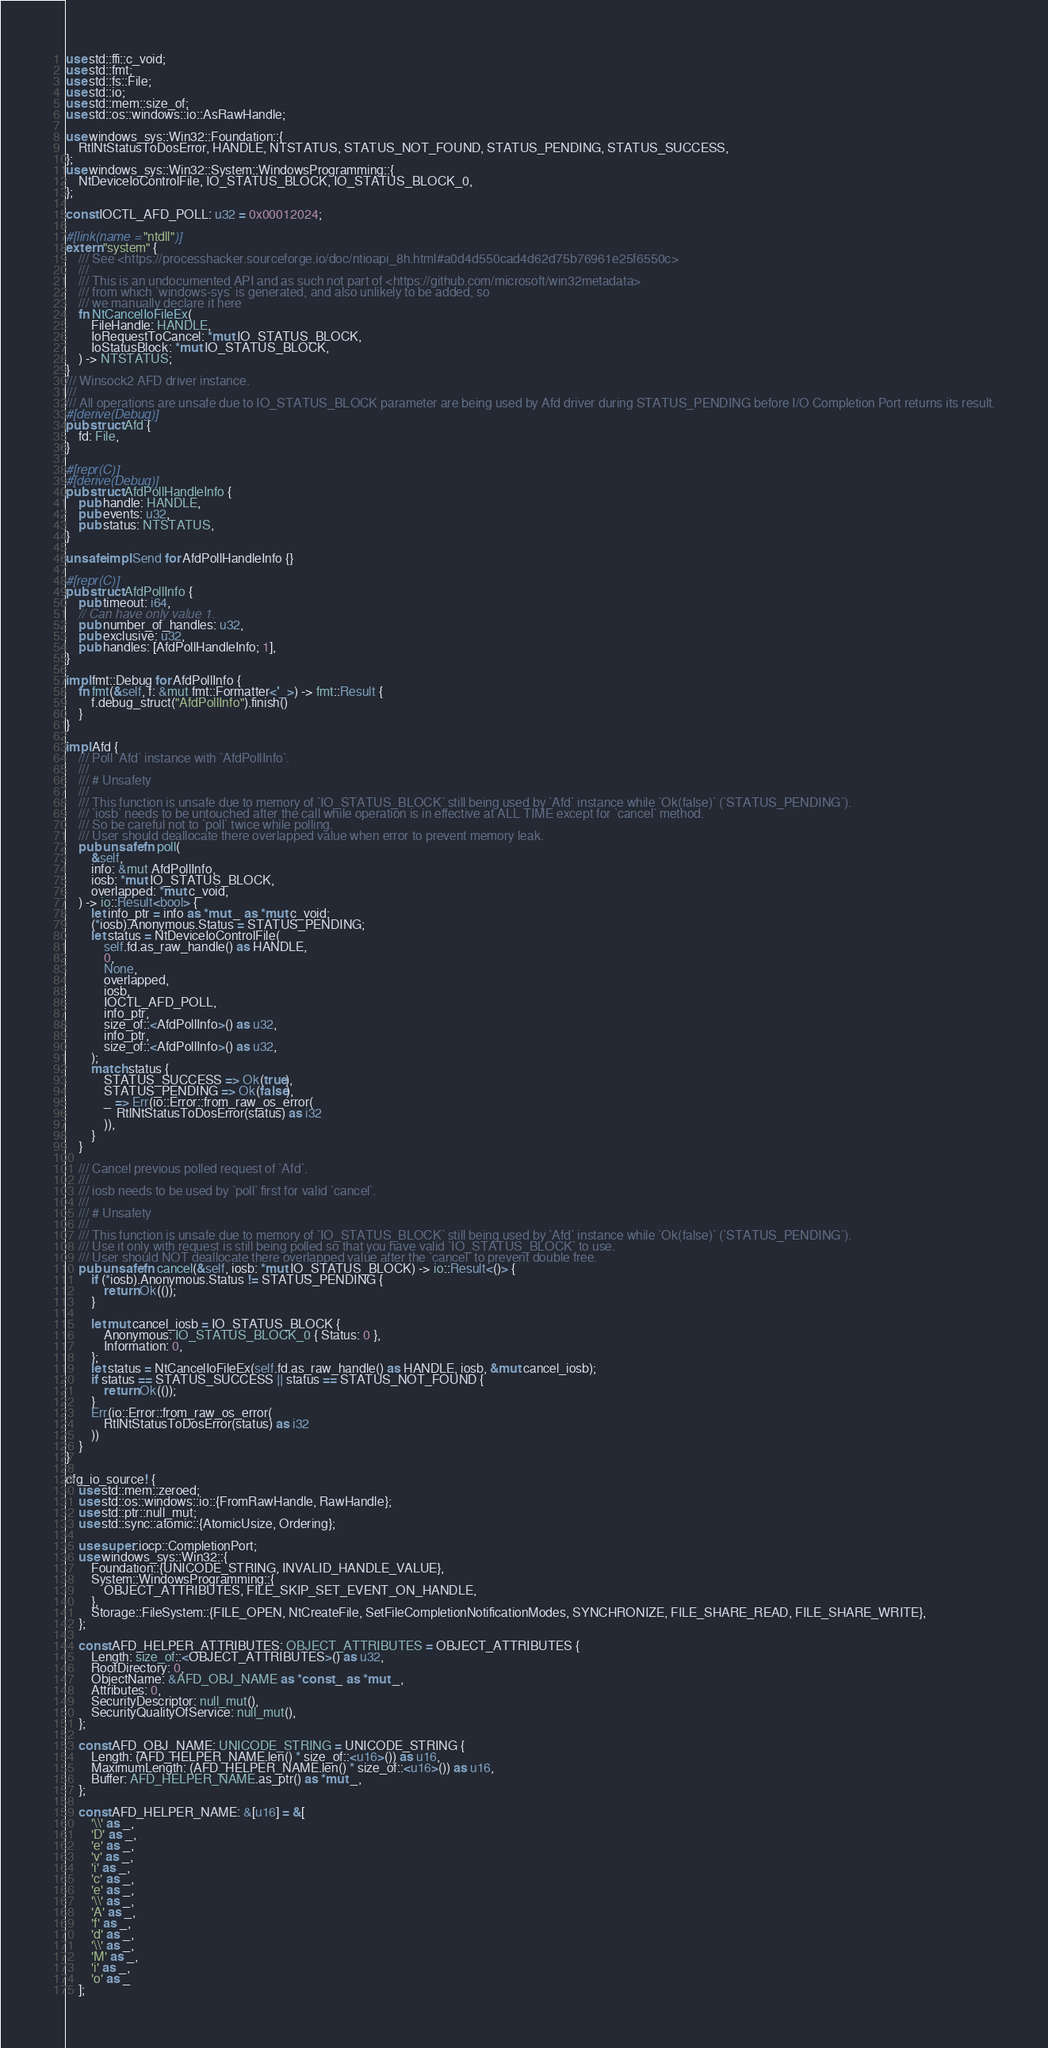<code> <loc_0><loc_0><loc_500><loc_500><_Rust_>use std::ffi::c_void;
use std::fmt;
use std::fs::File;
use std::io;
use std::mem::size_of;
use std::os::windows::io::AsRawHandle;

use windows_sys::Win32::Foundation::{
    RtlNtStatusToDosError, HANDLE, NTSTATUS, STATUS_NOT_FOUND, STATUS_PENDING, STATUS_SUCCESS,
};
use windows_sys::Win32::System::WindowsProgramming::{
    NtDeviceIoControlFile, IO_STATUS_BLOCK, IO_STATUS_BLOCK_0,
};

const IOCTL_AFD_POLL: u32 = 0x00012024;

#[link(name = "ntdll")]
extern "system" {
    /// See <https://processhacker.sourceforge.io/doc/ntioapi_8h.html#a0d4d550cad4d62d75b76961e25f6550c>
    ///
    /// This is an undocumented API and as such not part of <https://github.com/microsoft/win32metadata>
    /// from which `windows-sys` is generated, and also unlikely to be added, so
    /// we manually declare it here
    fn NtCancelIoFileEx(
        FileHandle: HANDLE,
        IoRequestToCancel: *mut IO_STATUS_BLOCK,
        IoStatusBlock: *mut IO_STATUS_BLOCK,
    ) -> NTSTATUS;
}
/// Winsock2 AFD driver instance.
///
/// All operations are unsafe due to IO_STATUS_BLOCK parameter are being used by Afd driver during STATUS_PENDING before I/O Completion Port returns its result.
#[derive(Debug)]
pub struct Afd {
    fd: File,
}

#[repr(C)]
#[derive(Debug)]
pub struct AfdPollHandleInfo {
    pub handle: HANDLE,
    pub events: u32,
    pub status: NTSTATUS,
}

unsafe impl Send for AfdPollHandleInfo {}

#[repr(C)]
pub struct AfdPollInfo {
    pub timeout: i64,
    // Can have only value 1.
    pub number_of_handles: u32,
    pub exclusive: u32,
    pub handles: [AfdPollHandleInfo; 1],
}

impl fmt::Debug for AfdPollInfo {
    fn fmt(&self, f: &mut fmt::Formatter<'_>) -> fmt::Result {
        f.debug_struct("AfdPollInfo").finish()
    }
}

impl Afd {
    /// Poll `Afd` instance with `AfdPollInfo`.
    ///
    /// # Unsafety
    ///
    /// This function is unsafe due to memory of `IO_STATUS_BLOCK` still being used by `Afd` instance while `Ok(false)` (`STATUS_PENDING`).
    /// `iosb` needs to be untouched after the call while operation is in effective at ALL TIME except for `cancel` method.
    /// So be careful not to `poll` twice while polling.
    /// User should deallocate there overlapped value when error to prevent memory leak.
    pub unsafe fn poll(
        &self,
        info: &mut AfdPollInfo,
        iosb: *mut IO_STATUS_BLOCK,
        overlapped: *mut c_void,
    ) -> io::Result<bool> {
        let info_ptr = info as *mut _ as *mut c_void;
        (*iosb).Anonymous.Status = STATUS_PENDING;
        let status = NtDeviceIoControlFile(
            self.fd.as_raw_handle() as HANDLE,
            0,
            None,
            overlapped,
            iosb,
            IOCTL_AFD_POLL,
            info_ptr,
            size_of::<AfdPollInfo>() as u32,
            info_ptr,
            size_of::<AfdPollInfo>() as u32,
        );
        match status {
            STATUS_SUCCESS => Ok(true),
            STATUS_PENDING => Ok(false),
            _ => Err(io::Error::from_raw_os_error(
                RtlNtStatusToDosError(status) as i32
            )),
        }
    }

    /// Cancel previous polled request of `Afd`.
    ///
    /// iosb needs to be used by `poll` first for valid `cancel`.
    ///
    /// # Unsafety
    ///
    /// This function is unsafe due to memory of `IO_STATUS_BLOCK` still being used by `Afd` instance while `Ok(false)` (`STATUS_PENDING`).
    /// Use it only with request is still being polled so that you have valid `IO_STATUS_BLOCK` to use.
    /// User should NOT deallocate there overlapped value after the `cancel` to prevent double free.
    pub unsafe fn cancel(&self, iosb: *mut IO_STATUS_BLOCK) -> io::Result<()> {
        if (*iosb).Anonymous.Status != STATUS_PENDING {
            return Ok(());
        }

        let mut cancel_iosb = IO_STATUS_BLOCK {
            Anonymous: IO_STATUS_BLOCK_0 { Status: 0 },
            Information: 0,
        };
        let status = NtCancelIoFileEx(self.fd.as_raw_handle() as HANDLE, iosb, &mut cancel_iosb);
        if status == STATUS_SUCCESS || status == STATUS_NOT_FOUND {
            return Ok(());
        }
        Err(io::Error::from_raw_os_error(
            RtlNtStatusToDosError(status) as i32
        ))
    }
}

cfg_io_source! {
    use std::mem::zeroed;
    use std::os::windows::io::{FromRawHandle, RawHandle};
    use std::ptr::null_mut;
    use std::sync::atomic::{AtomicUsize, Ordering};

    use super::iocp::CompletionPort;
    use windows_sys::Win32::{
        Foundation::{UNICODE_STRING, INVALID_HANDLE_VALUE},
        System::WindowsProgramming::{
            OBJECT_ATTRIBUTES, FILE_SKIP_SET_EVENT_ON_HANDLE,
        },
        Storage::FileSystem::{FILE_OPEN, NtCreateFile, SetFileCompletionNotificationModes, SYNCHRONIZE, FILE_SHARE_READ, FILE_SHARE_WRITE},
    };

    const AFD_HELPER_ATTRIBUTES: OBJECT_ATTRIBUTES = OBJECT_ATTRIBUTES {
        Length: size_of::<OBJECT_ATTRIBUTES>() as u32,
        RootDirectory: 0,
        ObjectName: &AFD_OBJ_NAME as *const _ as *mut _,
        Attributes: 0,
        SecurityDescriptor: null_mut(),
        SecurityQualityOfService: null_mut(),
    };

    const AFD_OBJ_NAME: UNICODE_STRING = UNICODE_STRING {
        Length: (AFD_HELPER_NAME.len() * size_of::<u16>()) as u16,
        MaximumLength: (AFD_HELPER_NAME.len() * size_of::<u16>()) as u16,
        Buffer: AFD_HELPER_NAME.as_ptr() as *mut _,
    };

    const AFD_HELPER_NAME: &[u16] = &[
        '\\' as _,
        'D' as _,
        'e' as _,
        'v' as _,
        'i' as _,
        'c' as _,
        'e' as _,
        '\\' as _,
        'A' as _,
        'f' as _,
        'd' as _,
        '\\' as _,
        'M' as _,
        'i' as _,
        'o' as _
    ];
</code> 